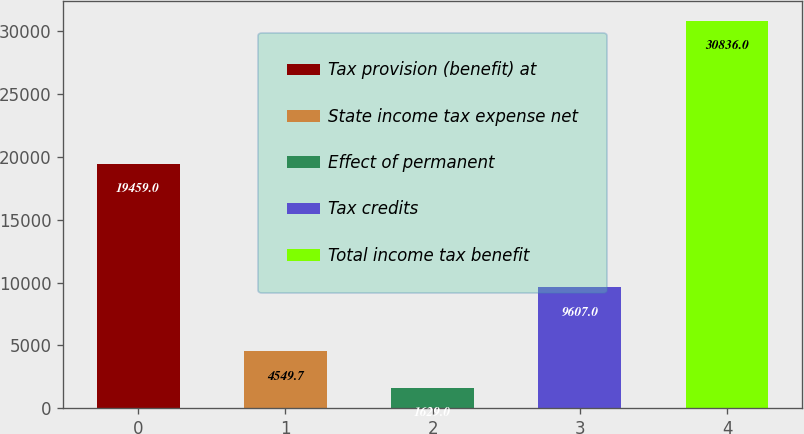<chart> <loc_0><loc_0><loc_500><loc_500><bar_chart><fcel>Tax provision (benefit) at<fcel>State income tax expense net<fcel>Effect of permanent<fcel>Tax credits<fcel>Total income tax benefit<nl><fcel>19459<fcel>4549.7<fcel>1629<fcel>9607<fcel>30836<nl></chart> 